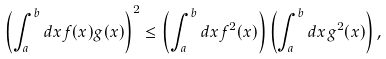<formula> <loc_0><loc_0><loc_500><loc_500>\left ( \int _ { a } ^ { b } d x f ( x ) g ( x ) \right ) ^ { 2 } \leq \left ( \int _ { a } ^ { b } d x f ^ { 2 } ( x ) \right ) \left ( \int _ { a } ^ { b } d x g ^ { 2 } ( x ) \right ) ,</formula> 